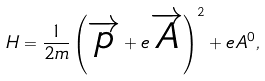Convert formula to latex. <formula><loc_0><loc_0><loc_500><loc_500>H = \frac { 1 } { 2 m } \left ( \overrightarrow { p } + e \overrightarrow { A } \right ) ^ { 2 } + e A ^ { 0 } ,</formula> 